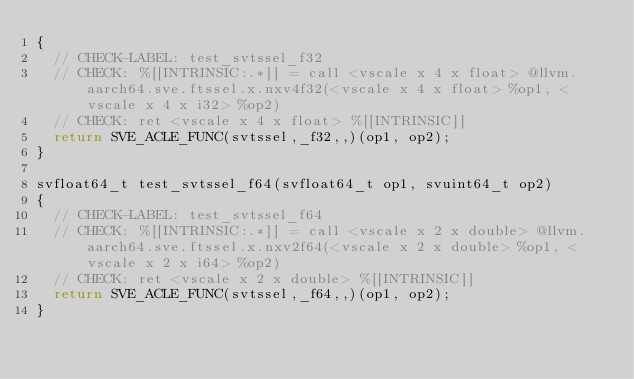Convert code to text. <code><loc_0><loc_0><loc_500><loc_500><_C_>{
  // CHECK-LABEL: test_svtssel_f32
  // CHECK: %[[INTRINSIC:.*]] = call <vscale x 4 x float> @llvm.aarch64.sve.ftssel.x.nxv4f32(<vscale x 4 x float> %op1, <vscale x 4 x i32> %op2)
  // CHECK: ret <vscale x 4 x float> %[[INTRINSIC]]
  return SVE_ACLE_FUNC(svtssel,_f32,,)(op1, op2);
}

svfloat64_t test_svtssel_f64(svfloat64_t op1, svuint64_t op2)
{
  // CHECK-LABEL: test_svtssel_f64
  // CHECK: %[[INTRINSIC:.*]] = call <vscale x 2 x double> @llvm.aarch64.sve.ftssel.x.nxv2f64(<vscale x 2 x double> %op1, <vscale x 2 x i64> %op2)
  // CHECK: ret <vscale x 2 x double> %[[INTRINSIC]]
  return SVE_ACLE_FUNC(svtssel,_f64,,)(op1, op2);
}
</code> 